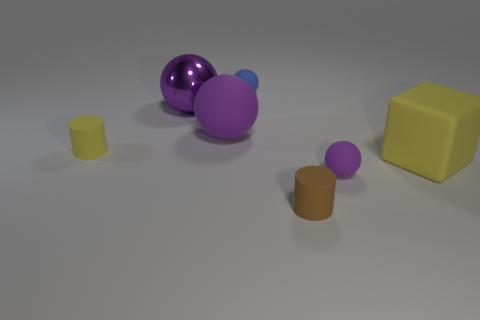What number of other objects are there of the same shape as the metallic thing?
Provide a short and direct response. 3. There is a purple object that is both on the right side of the shiny object and left of the tiny brown thing; what is it made of?
Make the answer very short. Rubber. What number of things are small metallic balls or small things?
Offer a very short reply. 4. Are there more matte cylinders than tiny brown rubber things?
Your response must be concise. Yes. How big is the matte cylinder on the right side of the tiny object on the left side of the blue ball?
Offer a terse response. Small. There is another small rubber thing that is the same shape as the brown matte thing; what color is it?
Provide a short and direct response. Yellow. The shiny object has what size?
Your answer should be compact. Large. How many cylinders are either tiny yellow rubber objects or purple objects?
Provide a short and direct response. 1. What size is the purple shiny object that is the same shape as the blue object?
Make the answer very short. Large. How many large yellow cubes are there?
Provide a short and direct response. 1. 